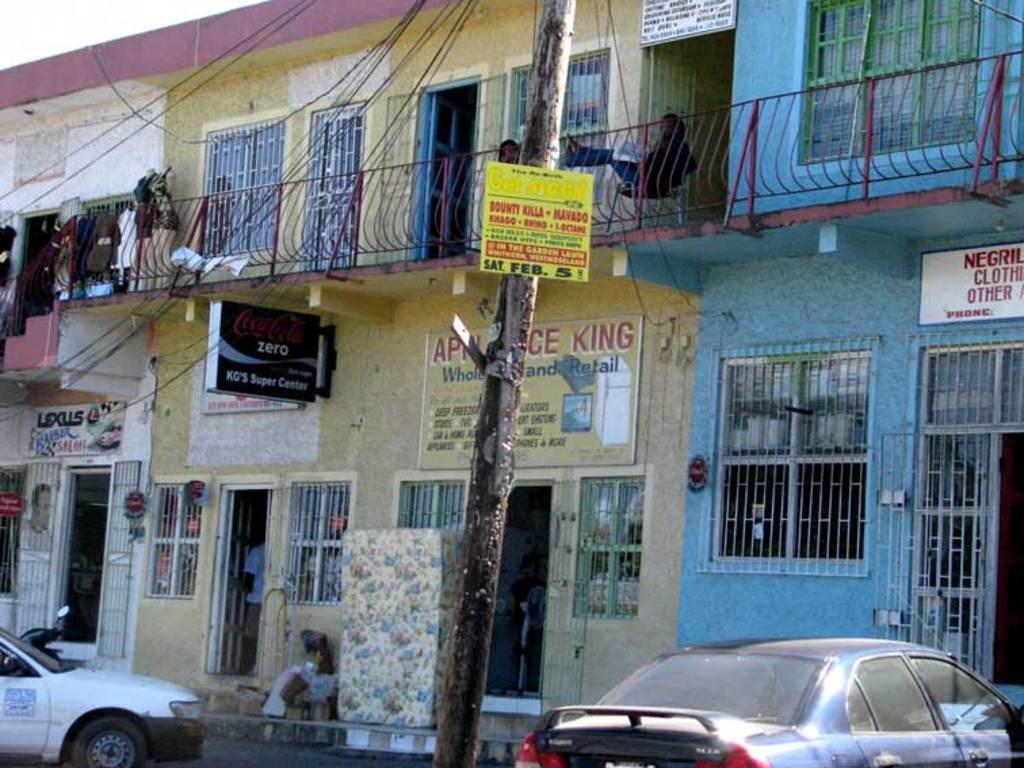Describe this image in one or two sentences. In this image we can see a person sitting on a chair in front of an iron railing placed on a building with windows on it. In the foreground of the image we can see two cars parked on the road. In the background we can see a pole, sign boards and sky. 